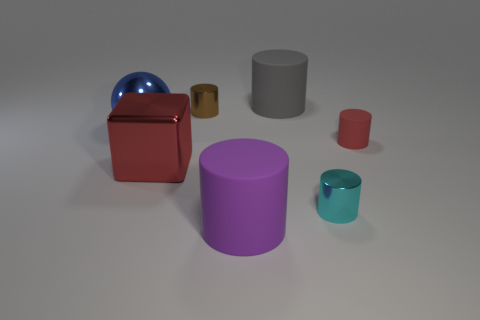Subtract all purple cylinders. How many cylinders are left? 4 Subtract 1 cylinders. How many cylinders are left? 4 Add 6 large gray cylinders. How many large gray cylinders are left? 7 Add 3 small brown rubber things. How many small brown rubber things exist? 3 Add 3 blue things. How many objects exist? 10 Subtract all purple cylinders. How many cylinders are left? 4 Subtract 0 green spheres. How many objects are left? 7 Subtract all balls. How many objects are left? 6 Subtract all gray cylinders. Subtract all red blocks. How many cylinders are left? 4 Subtract all purple cubes. How many purple cylinders are left? 1 